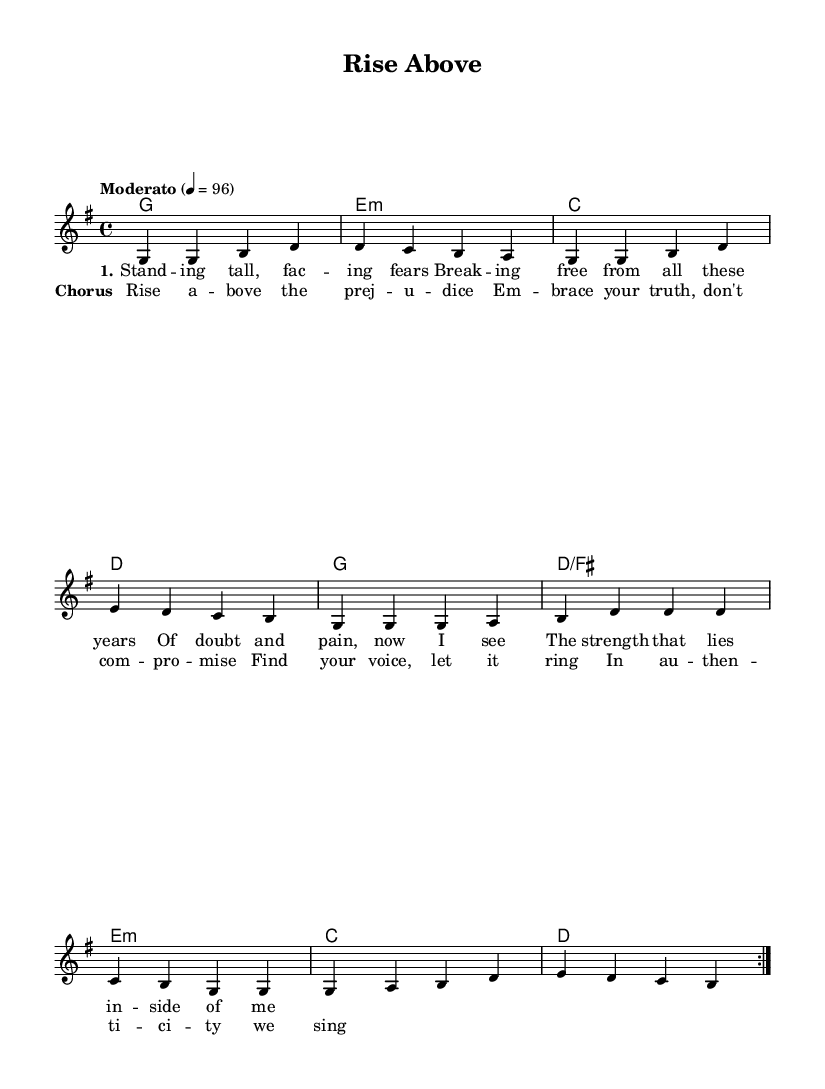What is the key signature of this music? The key signature indicates G major, which has one sharp (F#). This is determined by the notation found at the beginning of the staff.
Answer: G major What is the time signature of this piece? The time signature is 4/4, indicated at the beginning of the score. This means there are four beats in each measure.
Answer: 4/4 What is the tempo marking for this composition? The tempo marking is "Moderato," indicating a moderate speed. This is noted at the start of the score along with the metronome marking of 96 beats per minute.
Answer: Moderato How many times is the verse section repeated? The verse section is noted to be repeated twice as indicated by "repeat volta 2" in the melody part. This signifies the intention of repeating the section before moving on.
Answer: Twice What themes are reflected in the chorus lyrics? The chorus lyrics emphasize empowerment and authenticity, highlighting themes of rising above prejudice and embracing one's truth. This can be deduced from the content of the lyrics themselves.
Answer: Empowerment and authenticity What is the first note of the melody in the piece? The first note of the melody is G, which can be seen in the first measure of the melody staff. This is the starting note and establishes the tone of the piece.
Answer: G How do the harmonies change in the chorus compared to the verse? In the harmonies, the chorus introduces a more uplifting progression and echoes themes of resolution. This is noticeable as the harmony shifts to emphasize the uplifting message in the lyrics.
Answer: Uplifting progression 